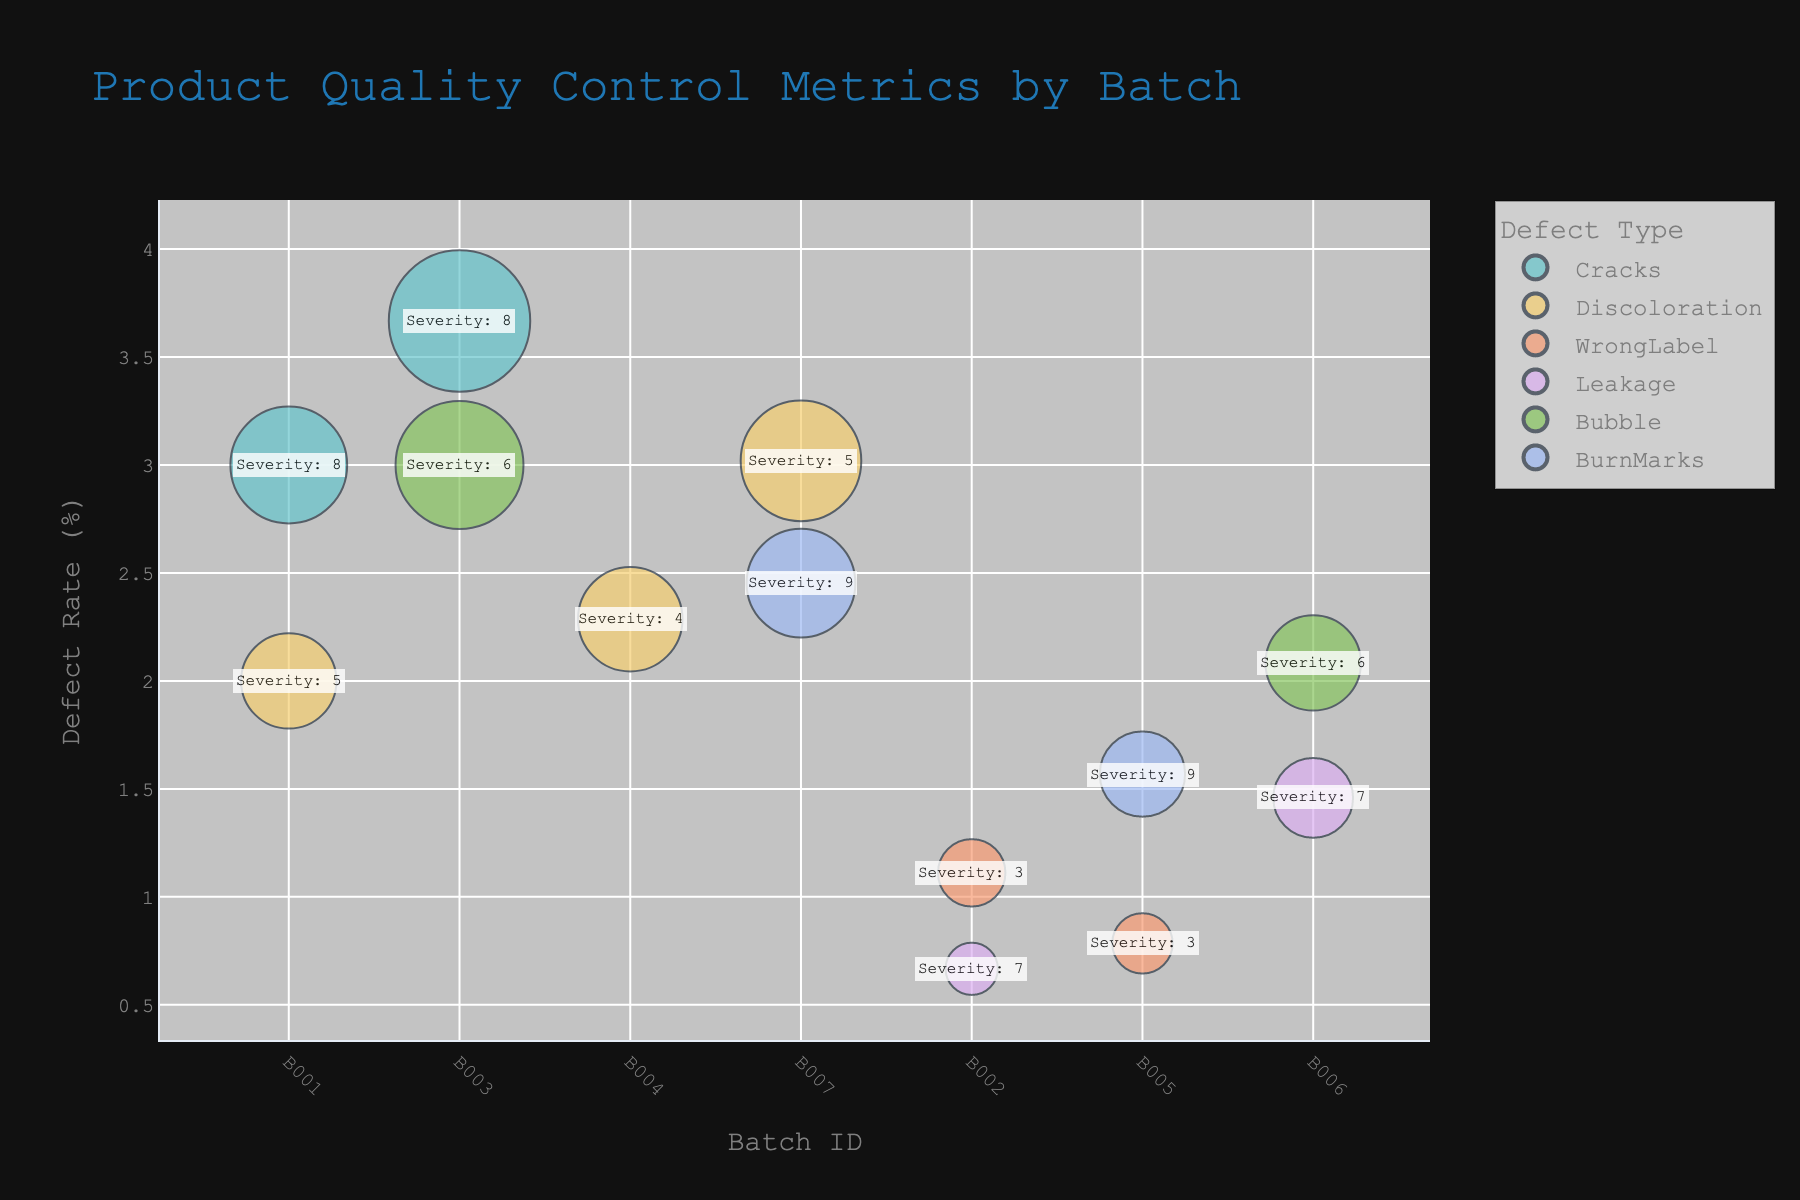What is the title of the bubble chart? The title of the bubble chart is written at the top of the figure. It's a natural language phrase summarizing the chart's subject.
Answer: Product Quality Control Metrics by Batch How many distinct defect types are shown in the figure? Count the distinct colors used in the bubbles, each representing a different defect type.
Answer: 7 Which batch has the highest defect rate? Look for the data point (bubble) with the highest position on the y-axis, which represents the defect rate. The batch ID at this position is the answer.
Answer: B007 What is the defect type with the highest defect count in Batch B001? Identify the bubbles corresponding to Batch B001 and compare their sizes. The largest bubble indicates the highest defect count. Check the color legend for the defect type it represents.
Answer: Cracks Compare the defect rates of batches B005 and B006. Which one is higher? Identify the bubbles for batches B005 and B006, then compare their positions on the y-axis. The bubble that is higher indicates the higher defect rate.
Answer: B005 What is the average defect rate across all batches? To find the average, sum all defect rates shown by the bubbles on the y-axis and divide by the number of batches (7 distinct Batch IDs).
Answer: 5 What is the total severity score for all Cracks defects? Identify all bubbles corresponding to the Cracks defect type, sum their severity scores (not visually shown, hence needing figure captions detailing scores or other info).
Answer: 24 Which batch has the largest bubble size, and what is its defect type? The largest bubble can be found by comparing all bubble sizes in the chart. The batch ID and defect type can be identified from this bubble.
Answer: B003, Cracks How does the severity score for B007-Discoloration compare to B006-Leakage? Look at the annotations on the bubbles representing B007-Discoloration and B006-Leakage, compare the annotated severity scores.
Answer: B007-Discoloration has a higher severity score Which batch shows the lowest defect rate, and what defect type does it correspond to? Identify the bubble that has the lowest position on the y-axis, getting the batch ID and defect type from that bubble.
Answer: B002, Leakage 